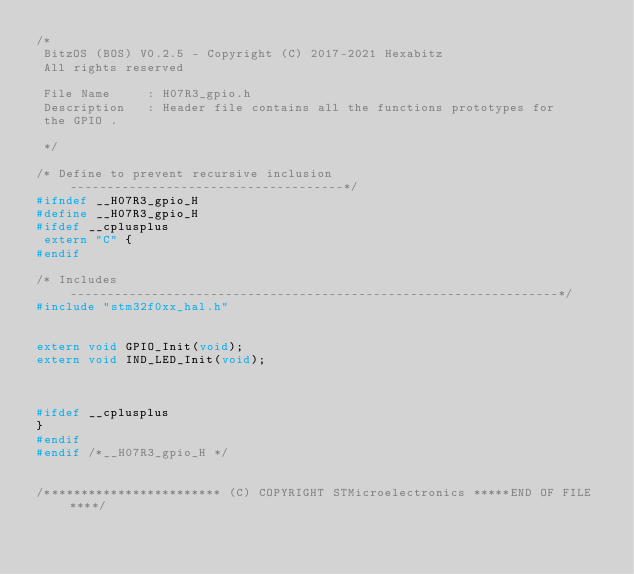<code> <loc_0><loc_0><loc_500><loc_500><_C_>/*
 BitzOS (BOS) V0.2.5 - Copyright (C) 2017-2021 Hexabitz
 All rights reserved

 File Name     : H07R3_gpio.h
 Description   : Header file contains all the functions prototypes for
 the GPIO .

 */

/* Define to prevent recursive inclusion -------------------------------------*/
#ifndef __H07R3_gpio_H
#define __H07R3_gpio_H
#ifdef __cplusplus
 extern "C" {
#endif

/* Includes ------------------------------------------------------------------*/
#include "stm32f0xx_hal.h"


extern void GPIO_Init(void);
extern void IND_LED_Init(void);
	 


#ifdef __cplusplus
}
#endif
#endif /*__H07R3_gpio_H */


/************************ (C) COPYRIGHT STMicroelectronics *****END OF FILE****/
</code> 